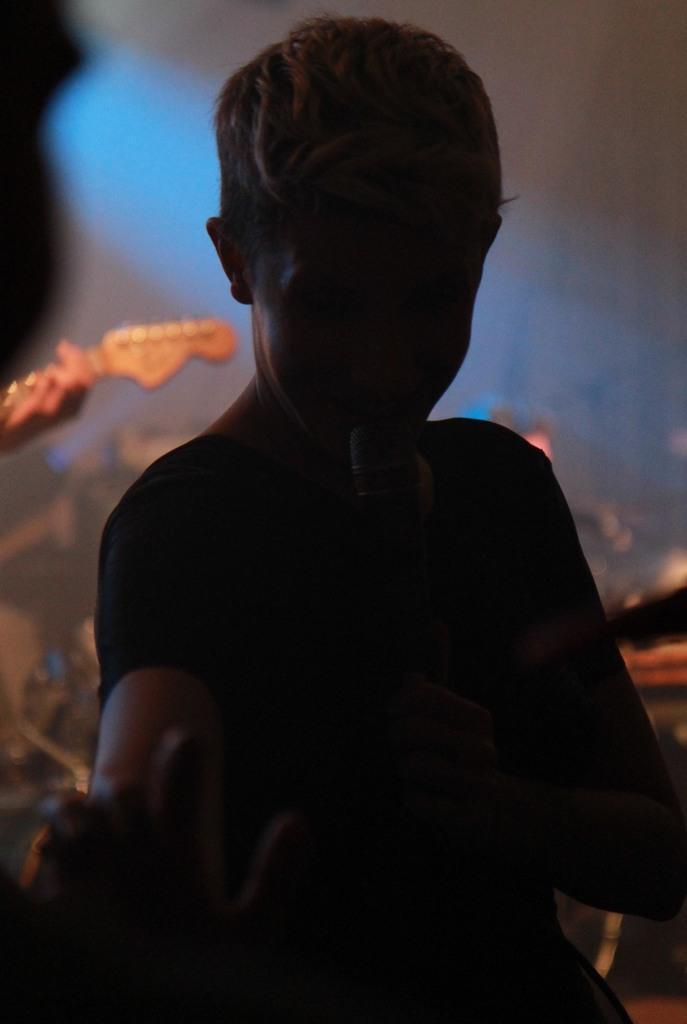Could you give a brief overview of what you see in this image? In this image there is a person holding the mike in his hand. In front of him we can see the hand of a person. Behind him there is a person and there are a few musical instruments. 